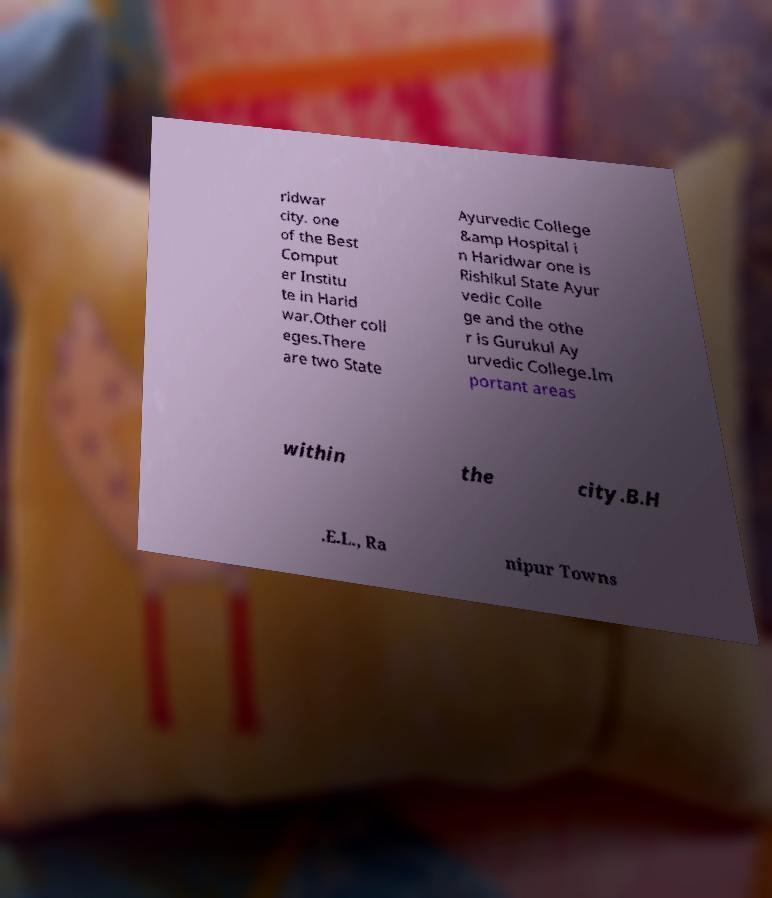What messages or text are displayed in this image? I need them in a readable, typed format. ridwar city. one of the Best Comput er Institu te in Harid war.Other coll eges.There are two State Ayurvedic College &amp Hospital i n Haridwar one is Rishikul State Ayur vedic Colle ge and the othe r is Gurukul Ay urvedic College.Im portant areas within the city.B.H .E.L., Ra nipur Towns 